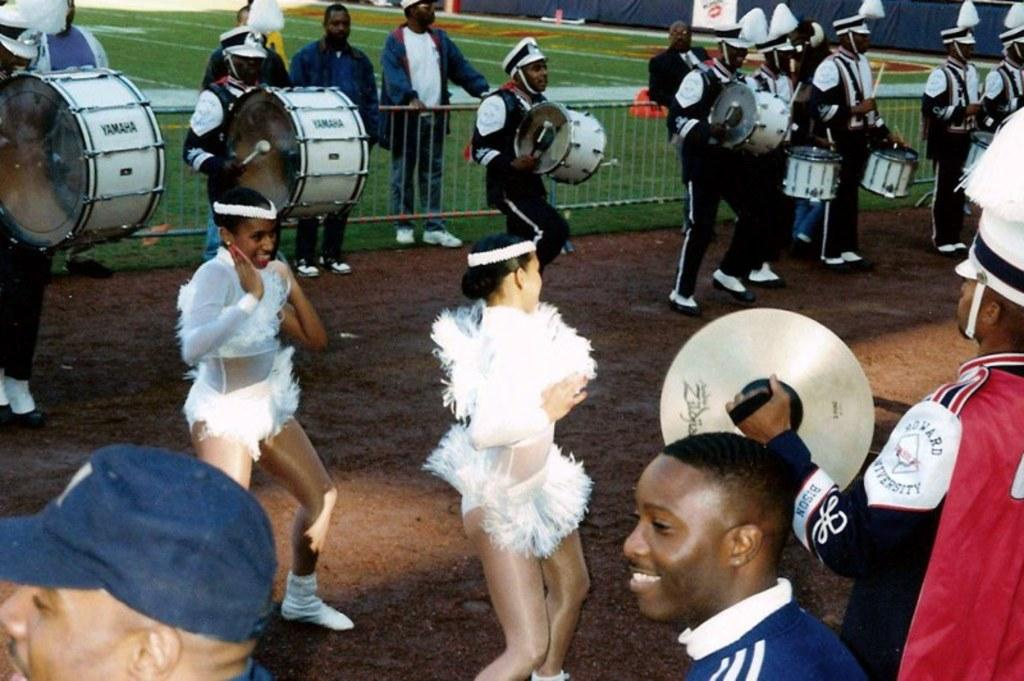What are the women in the image doing? The women in the image are dancing. What are the women wearing while dancing? The women are wearing white dresses. What other activity is happening in the image? There are persons playing musical drums in the image. What is the color of the grass in the image? The grass is green in color. How far are the persons from the camera in the image? The persons are standing far from the camera. What type of screw can be seen holding the tub in the image? There is no screw or tub present in the image; it features two women dancing and persons playing musical drums. 